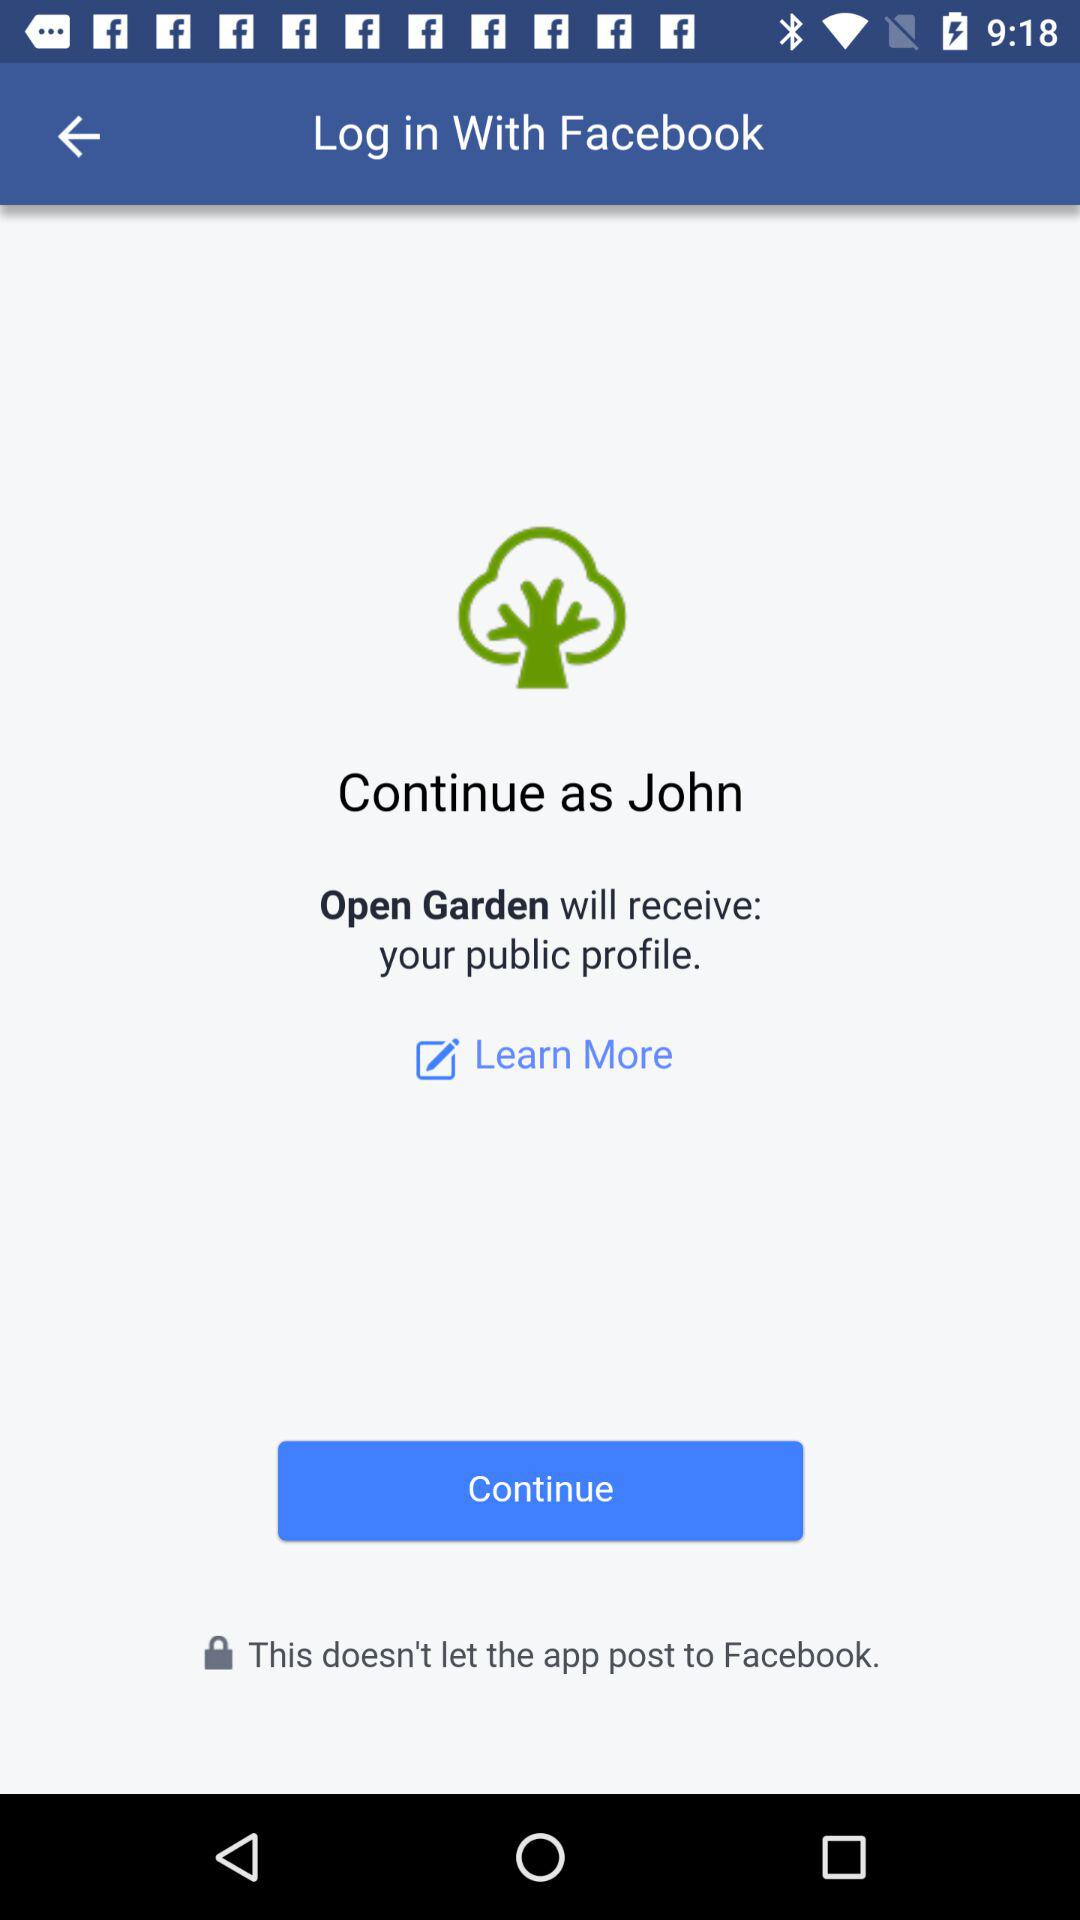What application are we accessing? You are accessing "Open Garden". 